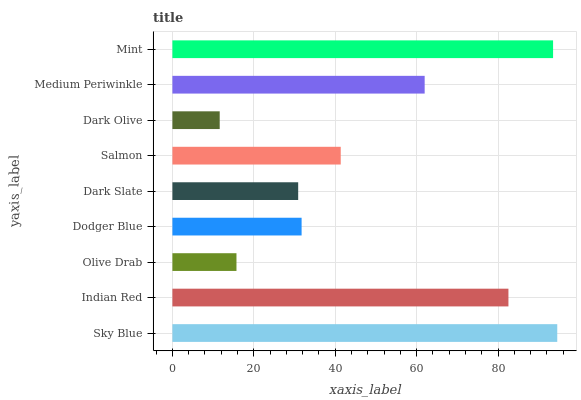Is Dark Olive the minimum?
Answer yes or no. Yes. Is Sky Blue the maximum?
Answer yes or no. Yes. Is Indian Red the minimum?
Answer yes or no. No. Is Indian Red the maximum?
Answer yes or no. No. Is Sky Blue greater than Indian Red?
Answer yes or no. Yes. Is Indian Red less than Sky Blue?
Answer yes or no. Yes. Is Indian Red greater than Sky Blue?
Answer yes or no. No. Is Sky Blue less than Indian Red?
Answer yes or no. No. Is Salmon the high median?
Answer yes or no. Yes. Is Salmon the low median?
Answer yes or no. Yes. Is Sky Blue the high median?
Answer yes or no. No. Is Indian Red the low median?
Answer yes or no. No. 